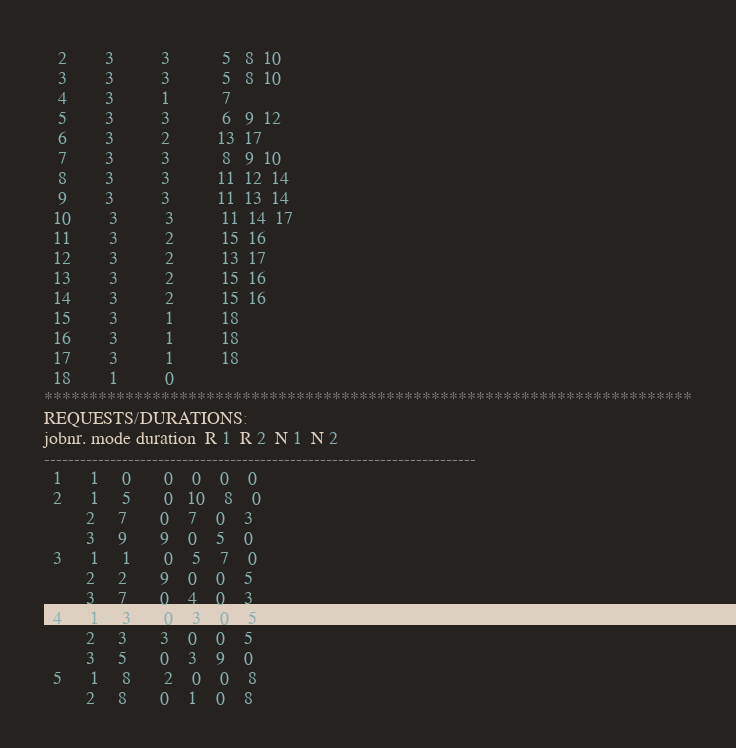Convert code to text. <code><loc_0><loc_0><loc_500><loc_500><_ObjectiveC_>   2        3          3           5   8  10
   3        3          3           5   8  10
   4        3          1           7
   5        3          3           6   9  12
   6        3          2          13  17
   7        3          3           8   9  10
   8        3          3          11  12  14
   9        3          3          11  13  14
  10        3          3          11  14  17
  11        3          2          15  16
  12        3          2          13  17
  13        3          2          15  16
  14        3          2          15  16
  15        3          1          18
  16        3          1          18
  17        3          1          18
  18        1          0        
************************************************************************
REQUESTS/DURATIONS:
jobnr. mode duration  R 1  R 2  N 1  N 2
------------------------------------------------------------------------
  1      1     0       0    0    0    0
  2      1     5       0   10    8    0
         2     7       0    7    0    3
         3     9       9    0    5    0
  3      1     1       0    5    7    0
         2     2       9    0    0    5
         3     7       0    4    0    3
  4      1     3       0    3    0    5
         2     3       3    0    0    5
         3     5       0    3    9    0
  5      1     8       2    0    0    8
         2     8       0    1    0    8</code> 